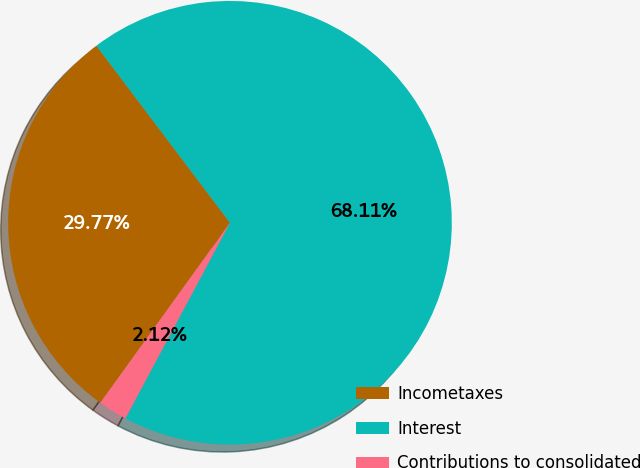<chart> <loc_0><loc_0><loc_500><loc_500><pie_chart><fcel>Incometaxes<fcel>Interest<fcel>Contributions to consolidated<nl><fcel>29.77%<fcel>68.1%<fcel>2.12%<nl></chart> 